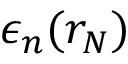Convert formula to latex. <formula><loc_0><loc_0><loc_500><loc_500>\epsilon _ { n } ( r _ { N } )</formula> 